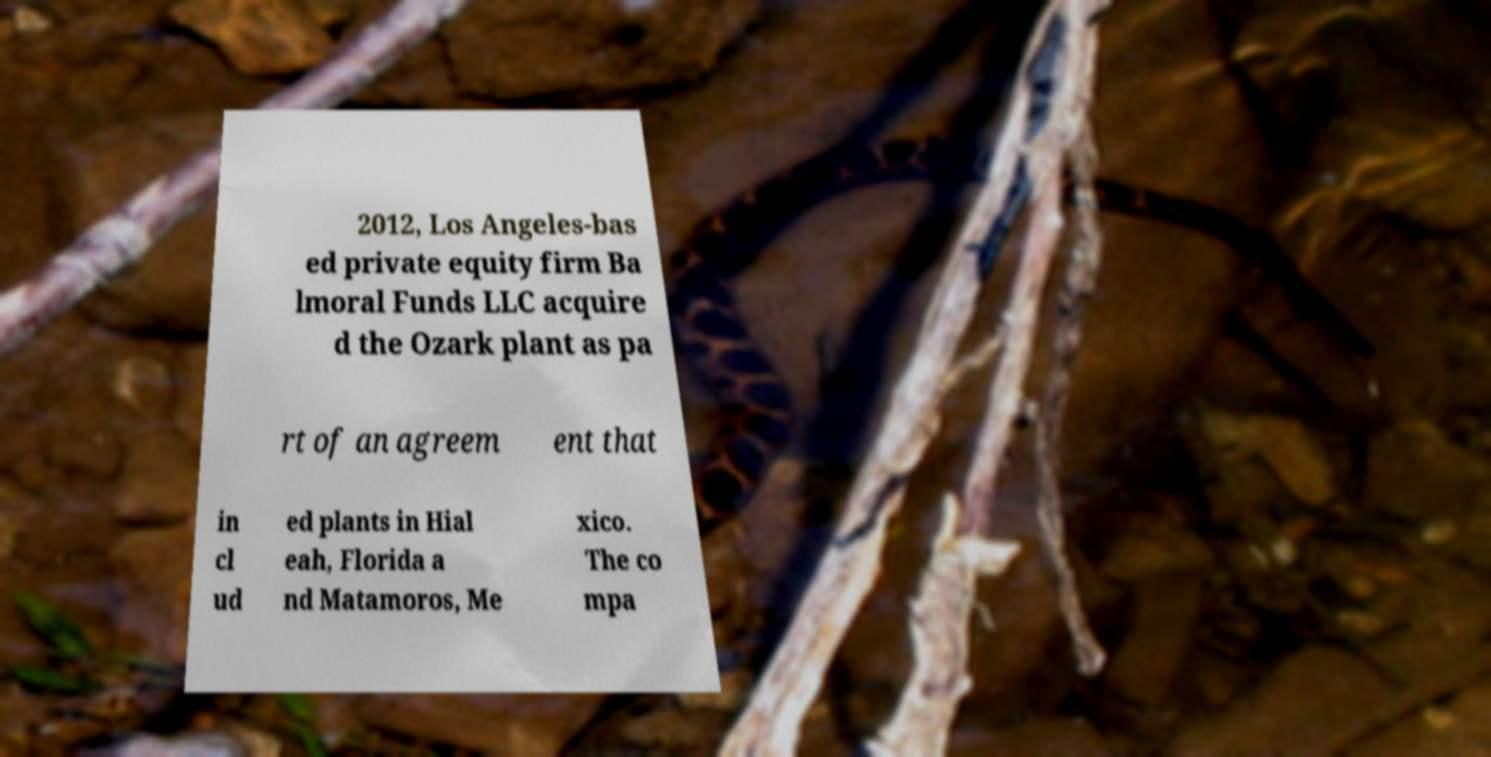Could you extract and type out the text from this image? 2012, Los Angeles-bas ed private equity firm Ba lmoral Funds LLC acquire d the Ozark plant as pa rt of an agreem ent that in cl ud ed plants in Hial eah, Florida a nd Matamoros, Me xico. The co mpa 